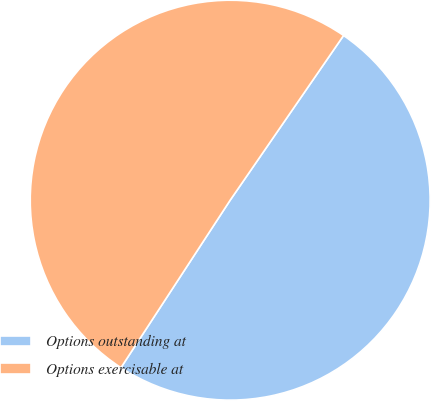Convert chart. <chart><loc_0><loc_0><loc_500><loc_500><pie_chart><fcel>Options outstanding at<fcel>Options exercisable at<nl><fcel>49.6%<fcel>50.4%<nl></chart> 